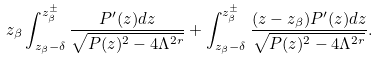Convert formula to latex. <formula><loc_0><loc_0><loc_500><loc_500>z _ { \beta } \int _ { z _ { \beta } - \delta } ^ { z _ { \beta } ^ { \pm } } \frac { P ^ { \prime } ( z ) d z } { \sqrt { P ( z ) ^ { 2 } - 4 \Lambda ^ { 2 r } } } + \int _ { z _ { \beta } - \delta } ^ { z _ { \beta } ^ { \pm } } \frac { ( z - z _ { \beta } ) P ^ { \prime } ( z ) d z } { \sqrt { P ( z ) ^ { 2 } - 4 \Lambda ^ { 2 r } } } .</formula> 